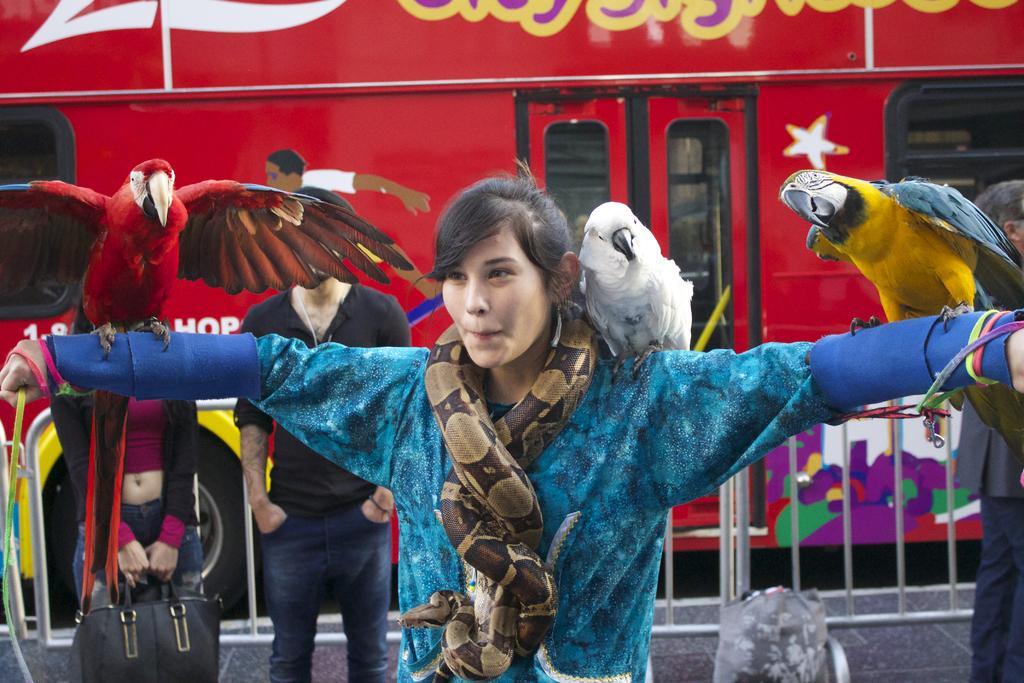Could you give a brief overview of what you see in this image? In this image there is a girl in the middle. There are three parrots on her shoulders. In the background there is a bus. Beside the bus there is a railing. On the left side there are two persons standing on the floor. 